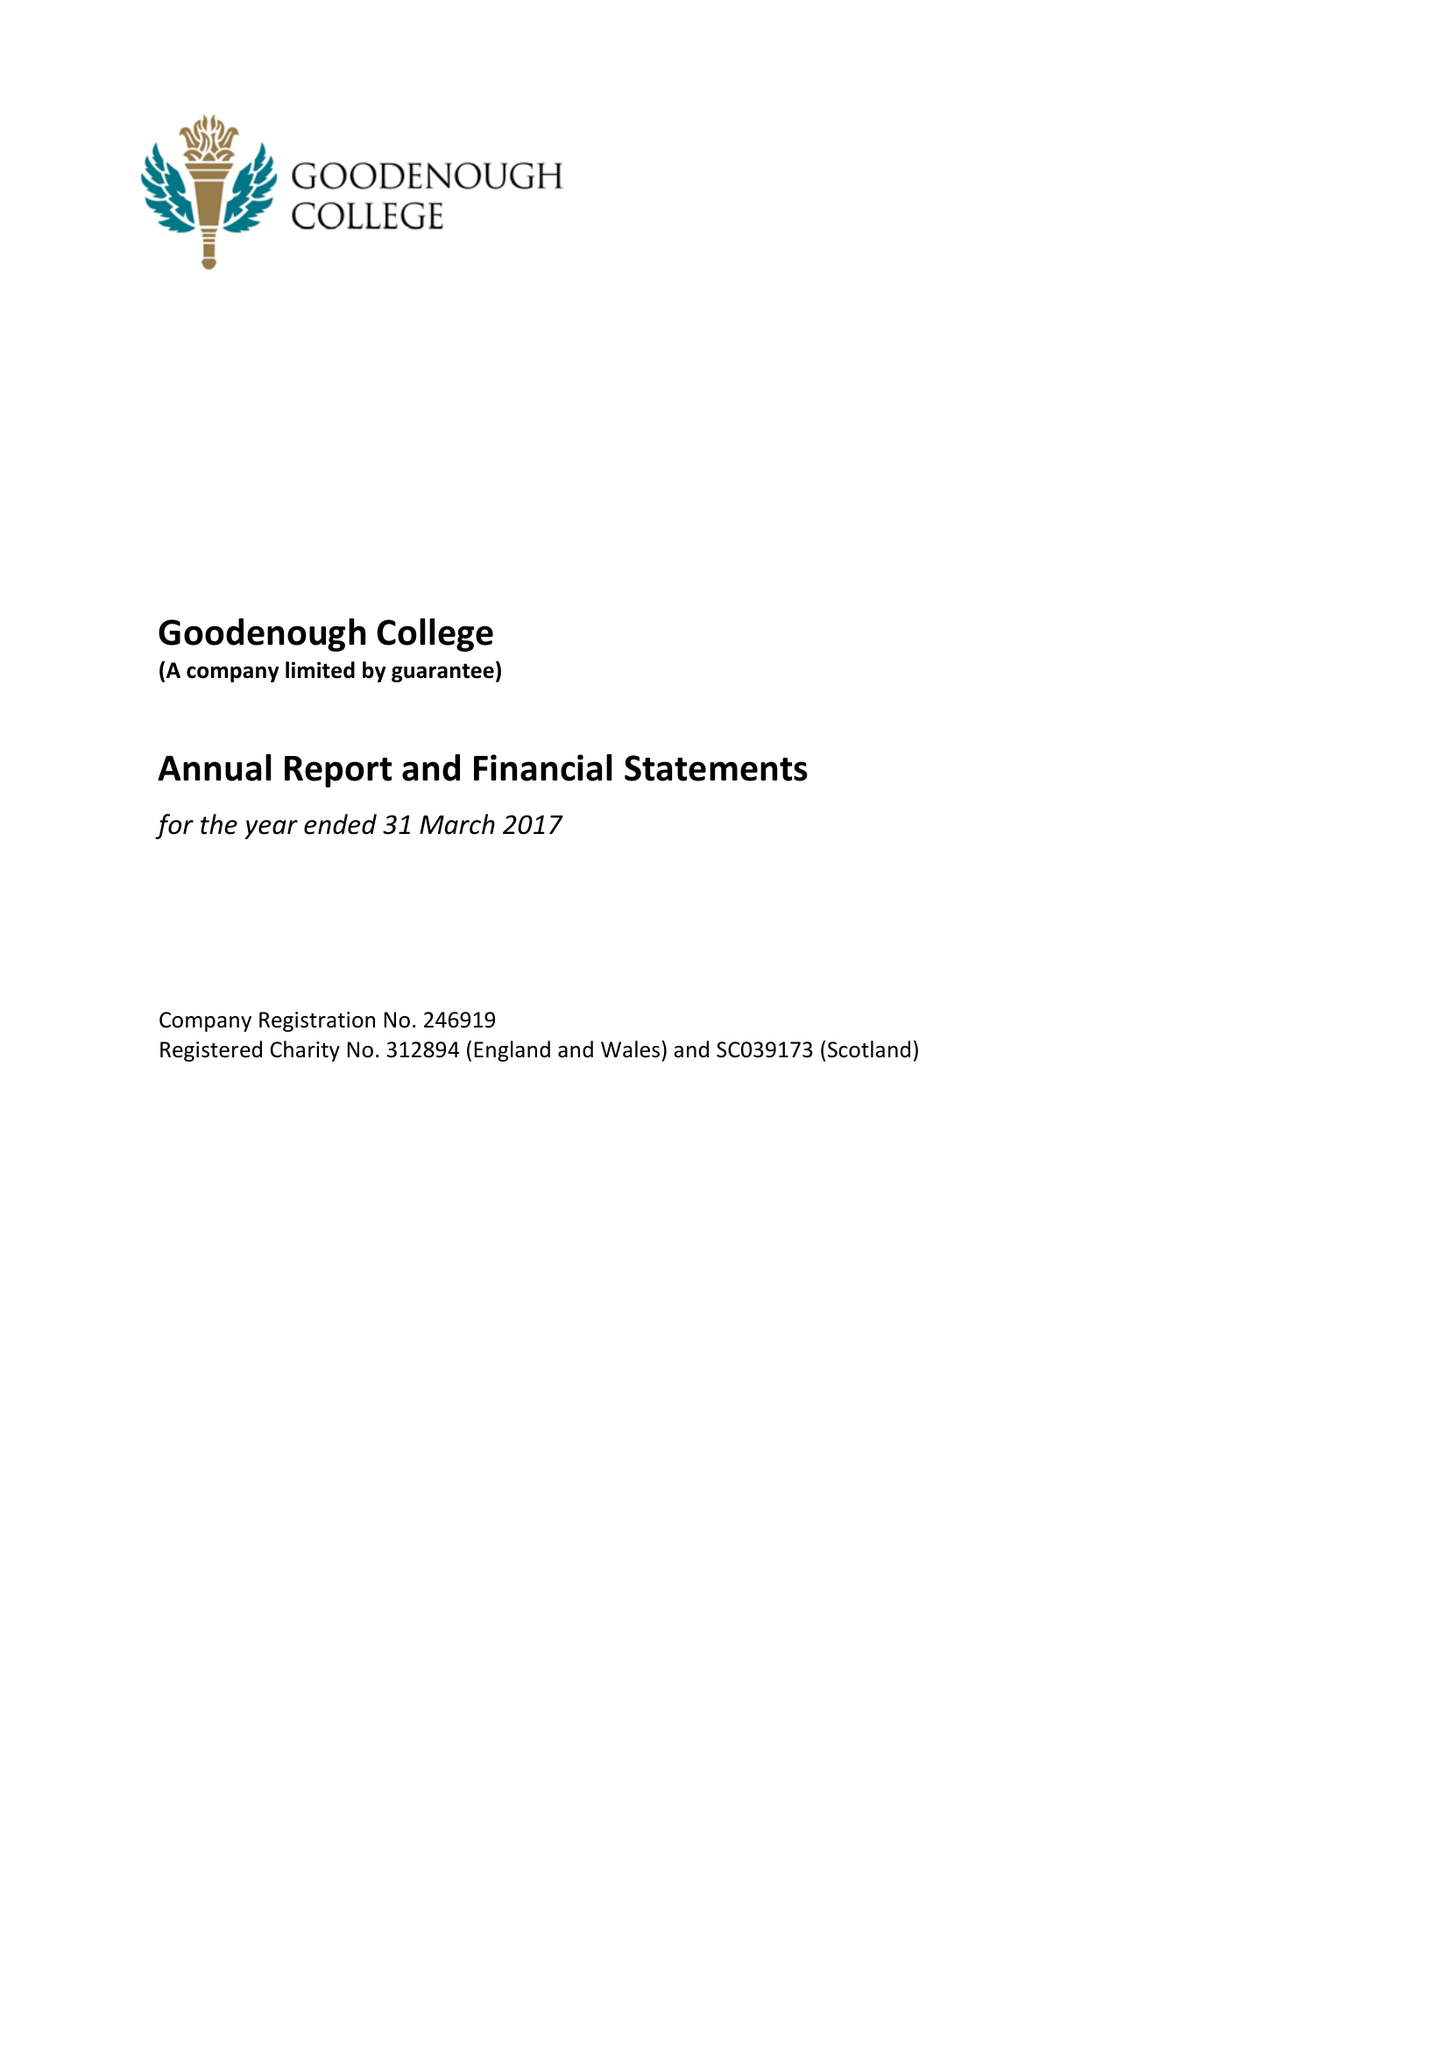What is the value for the address__street_line?
Answer the question using a single word or phrase. MECKLENBURGH SQUARE 